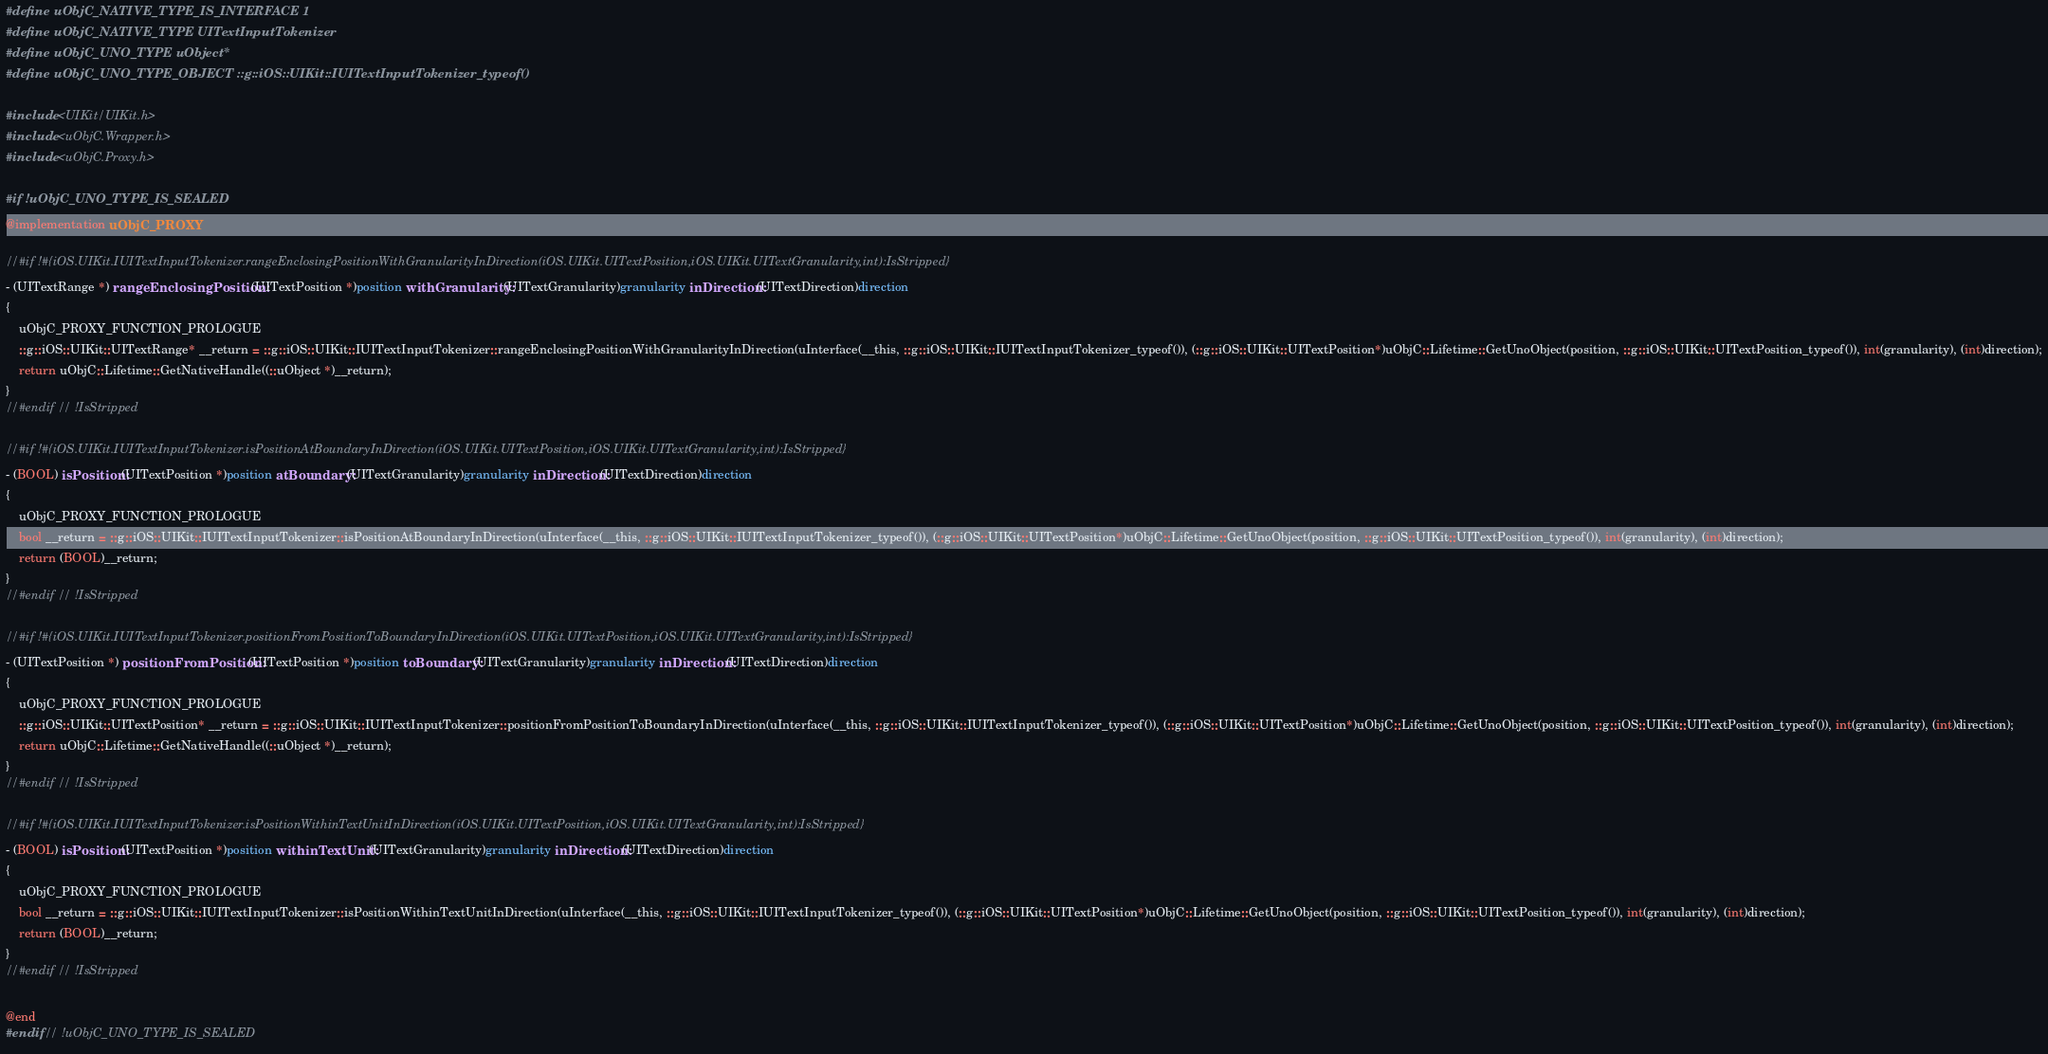<code> <loc_0><loc_0><loc_500><loc_500><_ObjectiveC_>#define uObjC_NATIVE_TYPE_IS_INTERFACE 1
#define uObjC_NATIVE_TYPE UITextInputTokenizer
#define uObjC_UNO_TYPE uObject*
#define uObjC_UNO_TYPE_OBJECT ::g::iOS::UIKit::IUITextInputTokenizer_typeof()

#include <UIKit/UIKit.h>
#include <uObjC.Wrapper.h>
#include <uObjC.Proxy.h>

#if !uObjC_UNO_TYPE_IS_SEALED
@implementation uObjC_PROXY

//#if !#{iOS.UIKit.IUITextInputTokenizer.rangeEnclosingPositionWithGranularityInDirection(iOS.UIKit.UITextPosition,iOS.UIKit.UITextGranularity,int):IsStripped}
- (UITextRange *) rangeEnclosingPosition:(UITextPosition *)position withGranularity:(UITextGranularity)granularity inDirection:(UITextDirection)direction
{
    uObjC_PROXY_FUNCTION_PROLOGUE
    ::g::iOS::UIKit::UITextRange* __return = ::g::iOS::UIKit::IUITextInputTokenizer::rangeEnclosingPositionWithGranularityInDirection(uInterface(__this, ::g::iOS::UIKit::IUITextInputTokenizer_typeof()), (::g::iOS::UIKit::UITextPosition*)uObjC::Lifetime::GetUnoObject(position, ::g::iOS::UIKit::UITextPosition_typeof()), int(granularity), (int)direction);
    return uObjC::Lifetime::GetNativeHandle((::uObject *)__return);
}
//#endif // !IsStripped

//#if !#{iOS.UIKit.IUITextInputTokenizer.isPositionAtBoundaryInDirection(iOS.UIKit.UITextPosition,iOS.UIKit.UITextGranularity,int):IsStripped}
- (BOOL) isPosition:(UITextPosition *)position atBoundary:(UITextGranularity)granularity inDirection:(UITextDirection)direction
{
    uObjC_PROXY_FUNCTION_PROLOGUE
    bool __return = ::g::iOS::UIKit::IUITextInputTokenizer::isPositionAtBoundaryInDirection(uInterface(__this, ::g::iOS::UIKit::IUITextInputTokenizer_typeof()), (::g::iOS::UIKit::UITextPosition*)uObjC::Lifetime::GetUnoObject(position, ::g::iOS::UIKit::UITextPosition_typeof()), int(granularity), (int)direction);
    return (BOOL)__return;
}
//#endif // !IsStripped

//#if !#{iOS.UIKit.IUITextInputTokenizer.positionFromPositionToBoundaryInDirection(iOS.UIKit.UITextPosition,iOS.UIKit.UITextGranularity,int):IsStripped}
- (UITextPosition *) positionFromPosition:(UITextPosition *)position toBoundary:(UITextGranularity)granularity inDirection:(UITextDirection)direction
{
    uObjC_PROXY_FUNCTION_PROLOGUE
    ::g::iOS::UIKit::UITextPosition* __return = ::g::iOS::UIKit::IUITextInputTokenizer::positionFromPositionToBoundaryInDirection(uInterface(__this, ::g::iOS::UIKit::IUITextInputTokenizer_typeof()), (::g::iOS::UIKit::UITextPosition*)uObjC::Lifetime::GetUnoObject(position, ::g::iOS::UIKit::UITextPosition_typeof()), int(granularity), (int)direction);
    return uObjC::Lifetime::GetNativeHandle((::uObject *)__return);
}
//#endif // !IsStripped

//#if !#{iOS.UIKit.IUITextInputTokenizer.isPositionWithinTextUnitInDirection(iOS.UIKit.UITextPosition,iOS.UIKit.UITextGranularity,int):IsStripped}
- (BOOL) isPosition:(UITextPosition *)position withinTextUnit:(UITextGranularity)granularity inDirection:(UITextDirection)direction
{
    uObjC_PROXY_FUNCTION_PROLOGUE
    bool __return = ::g::iOS::UIKit::IUITextInputTokenizer::isPositionWithinTextUnitInDirection(uInterface(__this, ::g::iOS::UIKit::IUITextInputTokenizer_typeof()), (::g::iOS::UIKit::UITextPosition*)uObjC::Lifetime::GetUnoObject(position, ::g::iOS::UIKit::UITextPosition_typeof()), int(granularity), (int)direction);
    return (BOOL)__return;
}
//#endif // !IsStripped

@end
#endif // !uObjC_UNO_TYPE_IS_SEALED
</code> 